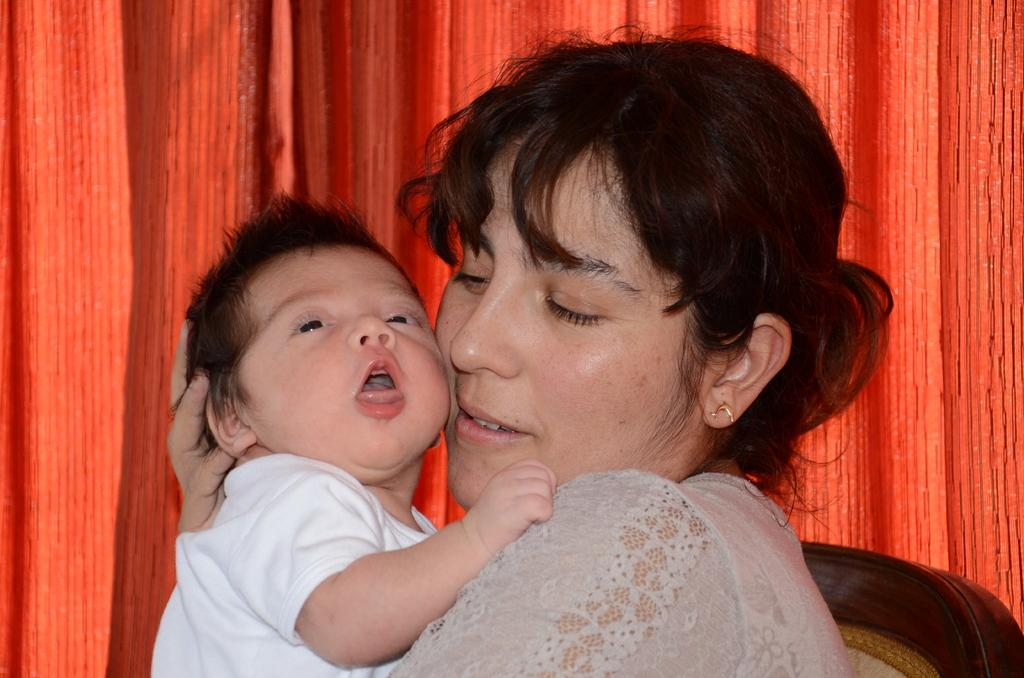Who is the main subject in the image? There is a woman in the image. What is the woman doing in the image? The woman is sitting on a chair and holding a baby in her hands. What else can be seen in the image? There is a curtain visible in the image. What color is the shoe that the woman is wearing in the image? There is no shoe visible in the image; the woman is holding a baby in her hands. 